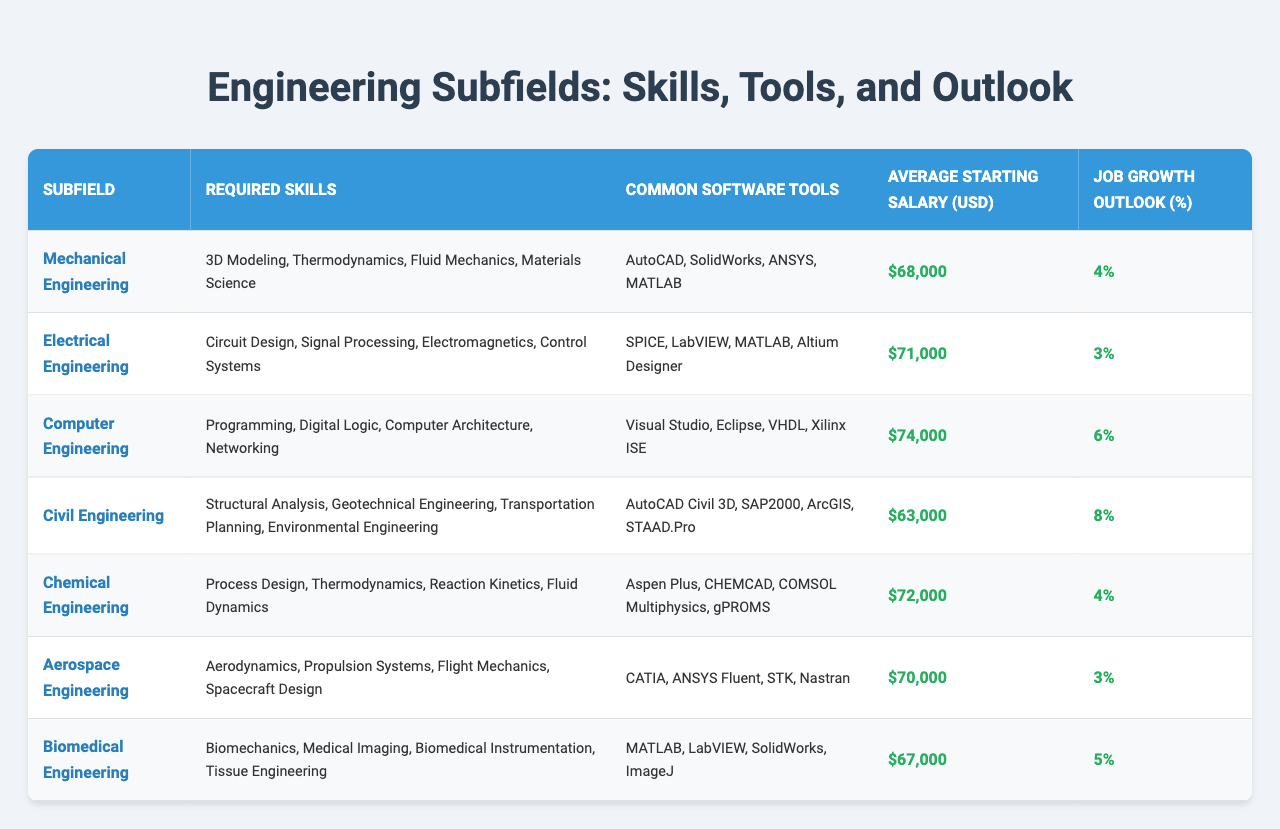What are the required skills for Computer Engineering? The table lists the required skills for Computer Engineering as Programming, Digital Logic, Computer Architecture, and Networking.
Answer: Programming, Digital Logic, Computer Architecture, Networking Which engineering subfield has the highest average starting salary? By comparing the average starting salaries listed in the table, Computer Engineering has the highest average starting salary at $74,000.
Answer: Computer Engineering How much higher is the average starting salary for Chemical Engineering compared to Civil Engineering? The average starting salary for Chemical Engineering is $72,000, while for Civil Engineering it is $63,000. The difference is $72,000 - $63,000 = $9,000.
Answer: $9,000 Are there more required skills for Aerospace Engineering or Biomedical Engineering? The required skills listed for Aerospace Engineering are Aerodynamics, Propulsion Systems, Flight Mechanics, and Spacecraft Design (4 skills), while Biomedical Engineering has Biomechanics, Medical Imaging, Biomedical Instrumentation, and Tissue Engineering (4 skills) as well. They have the same number of required skills.
Answer: No, they are equal What is the job growth outlook for Electrical Engineering? The table shows that the job growth outlook for Electrical Engineering is 3%.
Answer: 3% Which engineering fields share a common software tool called MATLAB? The table indicates that MATLAB is used in Mechanical Engineering, Electrical Engineering, Computer Engineering, and Biomedical Engineering.
Answer: Mechanical Engineering, Electrical Engineering, Computer Engineering, Biomedical Engineering What is the average starting salary for the engineering fields with a job growth outlook of 4%? The engineering fields with a job growth outlook of 4% are Mechanical Engineering and Chemical Engineering, with average starting salaries of $68,000 and $72,000 respectively. The average of these two salaries is ($68,000 + $72,000) / 2 = $70,000.
Answer: $70,000 Which subfield can expect the best job growth and what is that percentage? By looking at the job growth outlook, Civil Engineering has the best job growth outlook at 8%.
Answer: 8% How does the average starting salary for Biomedical Engineering compare to the average for Electrical Engineering? The average starting salary for Biomedical Engineering is $67,000, while for Electrical Engineering it is $71,000. The difference is $71,000 - $67,000 = $4,000.
Answer: $4,000 Which engineering subfield has the least required skills? Each engineering subfield has 4 required skills, hence no subfield has fewer required skills than the others.
Answer: None, all have the same 